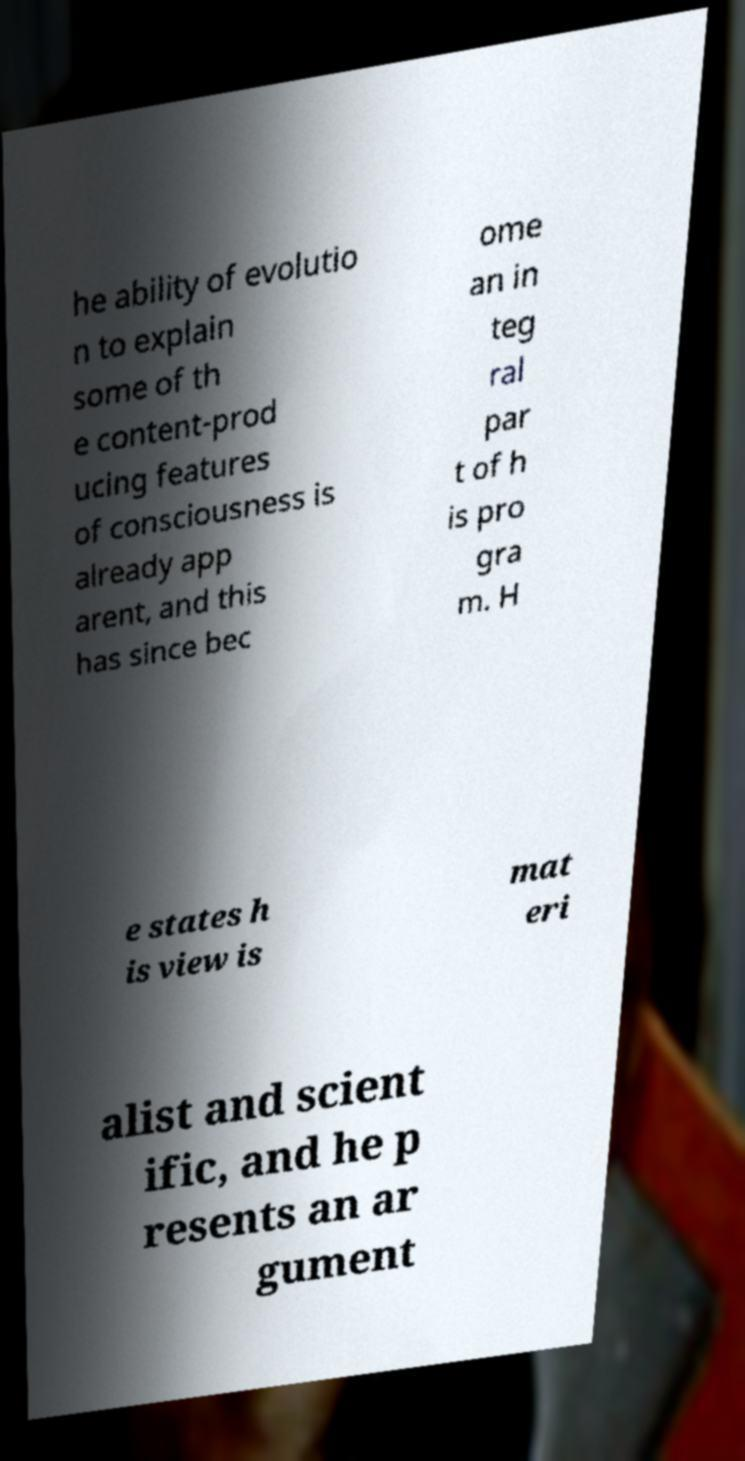Please read and relay the text visible in this image. What does it say? he ability of evolutio n to explain some of th e content-prod ucing features of consciousness is already app arent, and this has since bec ome an in teg ral par t of h is pro gra m. H e states h is view is mat eri alist and scient ific, and he p resents an ar gument 